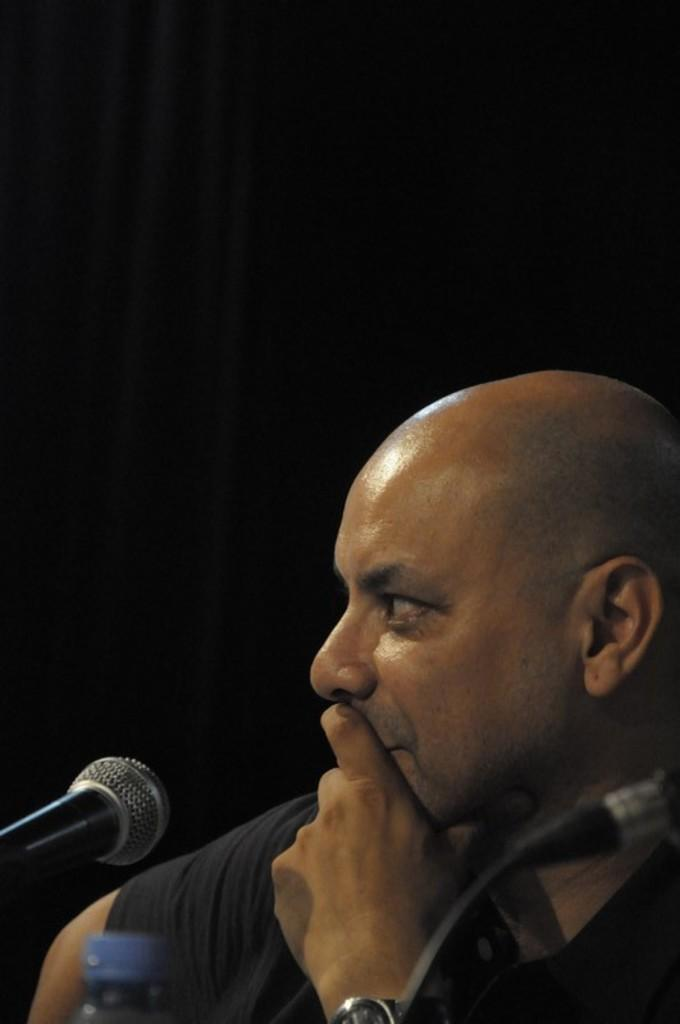Who or what is the main subject in the center of the image? There is a person in the center of the image. What object is associated with the person in the image? There is a microphone (mic) in the image. What other object can be seen in the image? There is a bottle in the image. What type of powder is being used by the farmer in the image? There is no farmer or powder present in the image. What kind of truck is visible in the image? There is no truck visible in the image. 